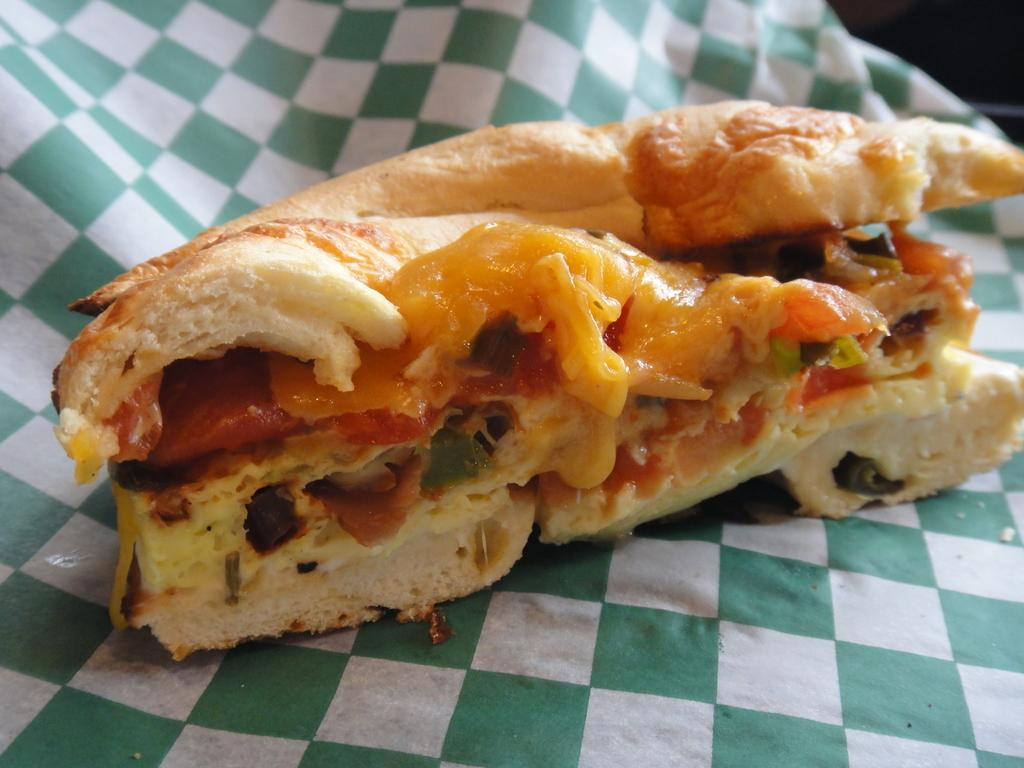What is located at the bottom of the image? There is a cloth in the image, and it is at the bottom. What can be seen in the foreground of the image? There is a food item in the foreground of the image. What type of calculator is being used by the fairies in the image? There are no fairies or calculators present in the image. 